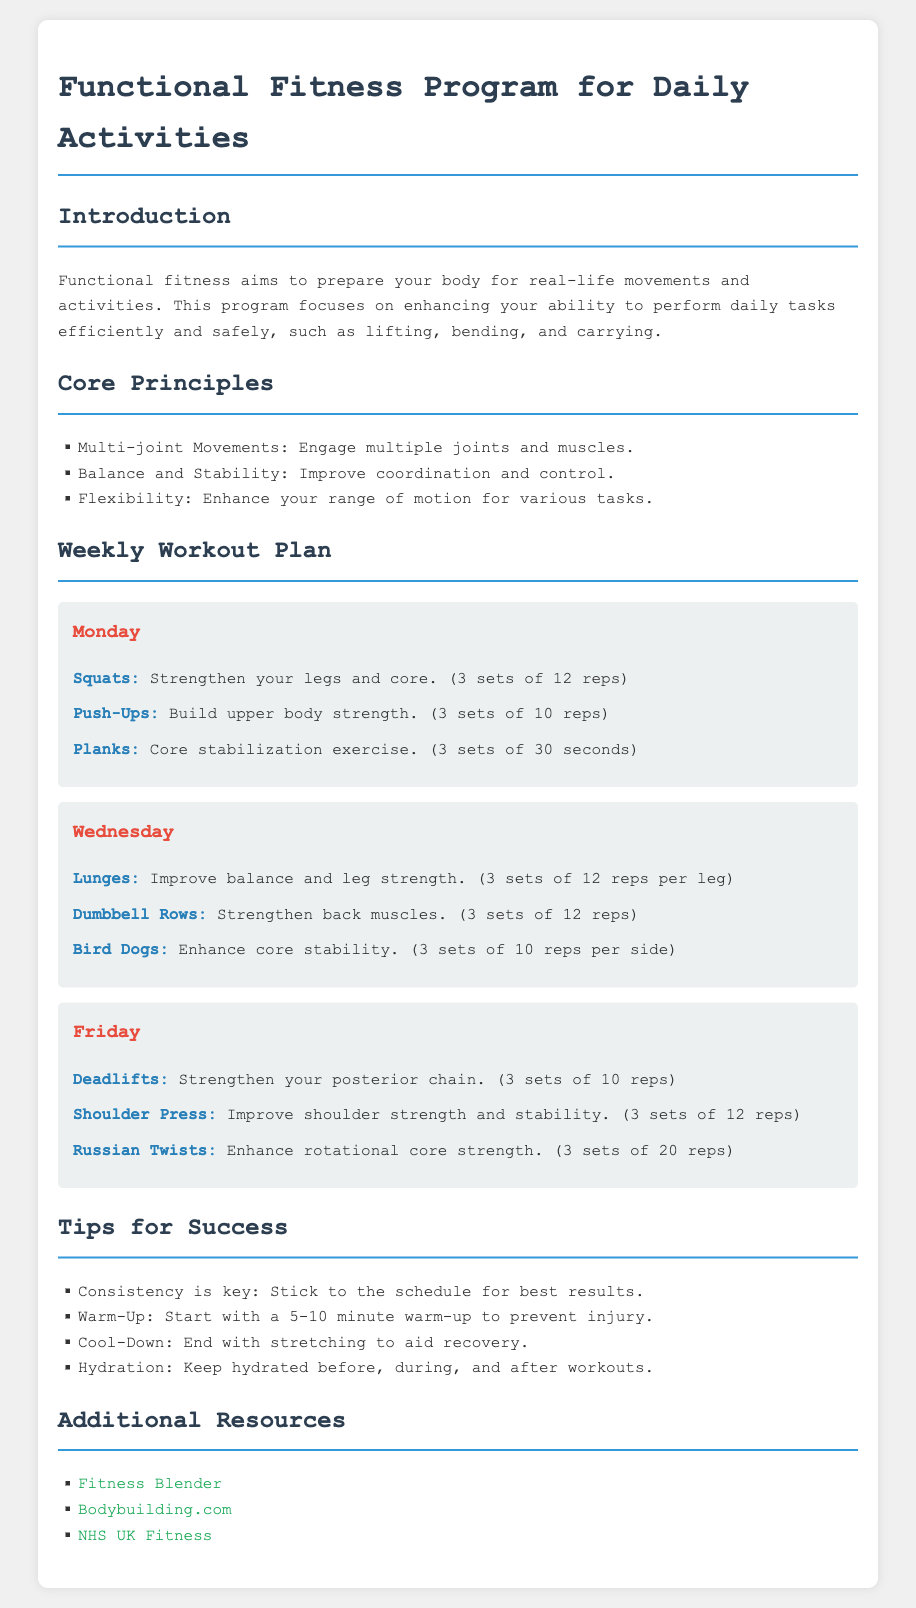What is the main goal of the Functional Fitness Program? The goal is to prepare your body for real-life movements and activities.
Answer: Prepare your body for real-life movements How many sets of Squats are recommended? It is mentioned in the Monday section of the workout plan as 3 sets.
Answer: 3 sets What exercise is included in the Wednesday workout for enhancing core stability? The exercise is explicitly listed in the Wednesday section as Bird Dogs.
Answer: Bird Dogs What is a key principle of functional fitness? One of the principles outlined in the document is balance and stability.
Answer: Balance and Stability How many exercises are listed for each workout day? Each workout day features three different exercises.
Answer: Three exercises What should you start with before the workout? The document advises beginning with a warm-up.
Answer: Warm-Up On which day are Deadlifts performed? The day that includes Deadlifts is specified in the Friday section.
Answer: Friday Which resource is linked for NHS UK Fitness? The document includes a specific URL for NHS UK Fitness.
Answer: https://www.nhs.uk/live-well/exercise/ 